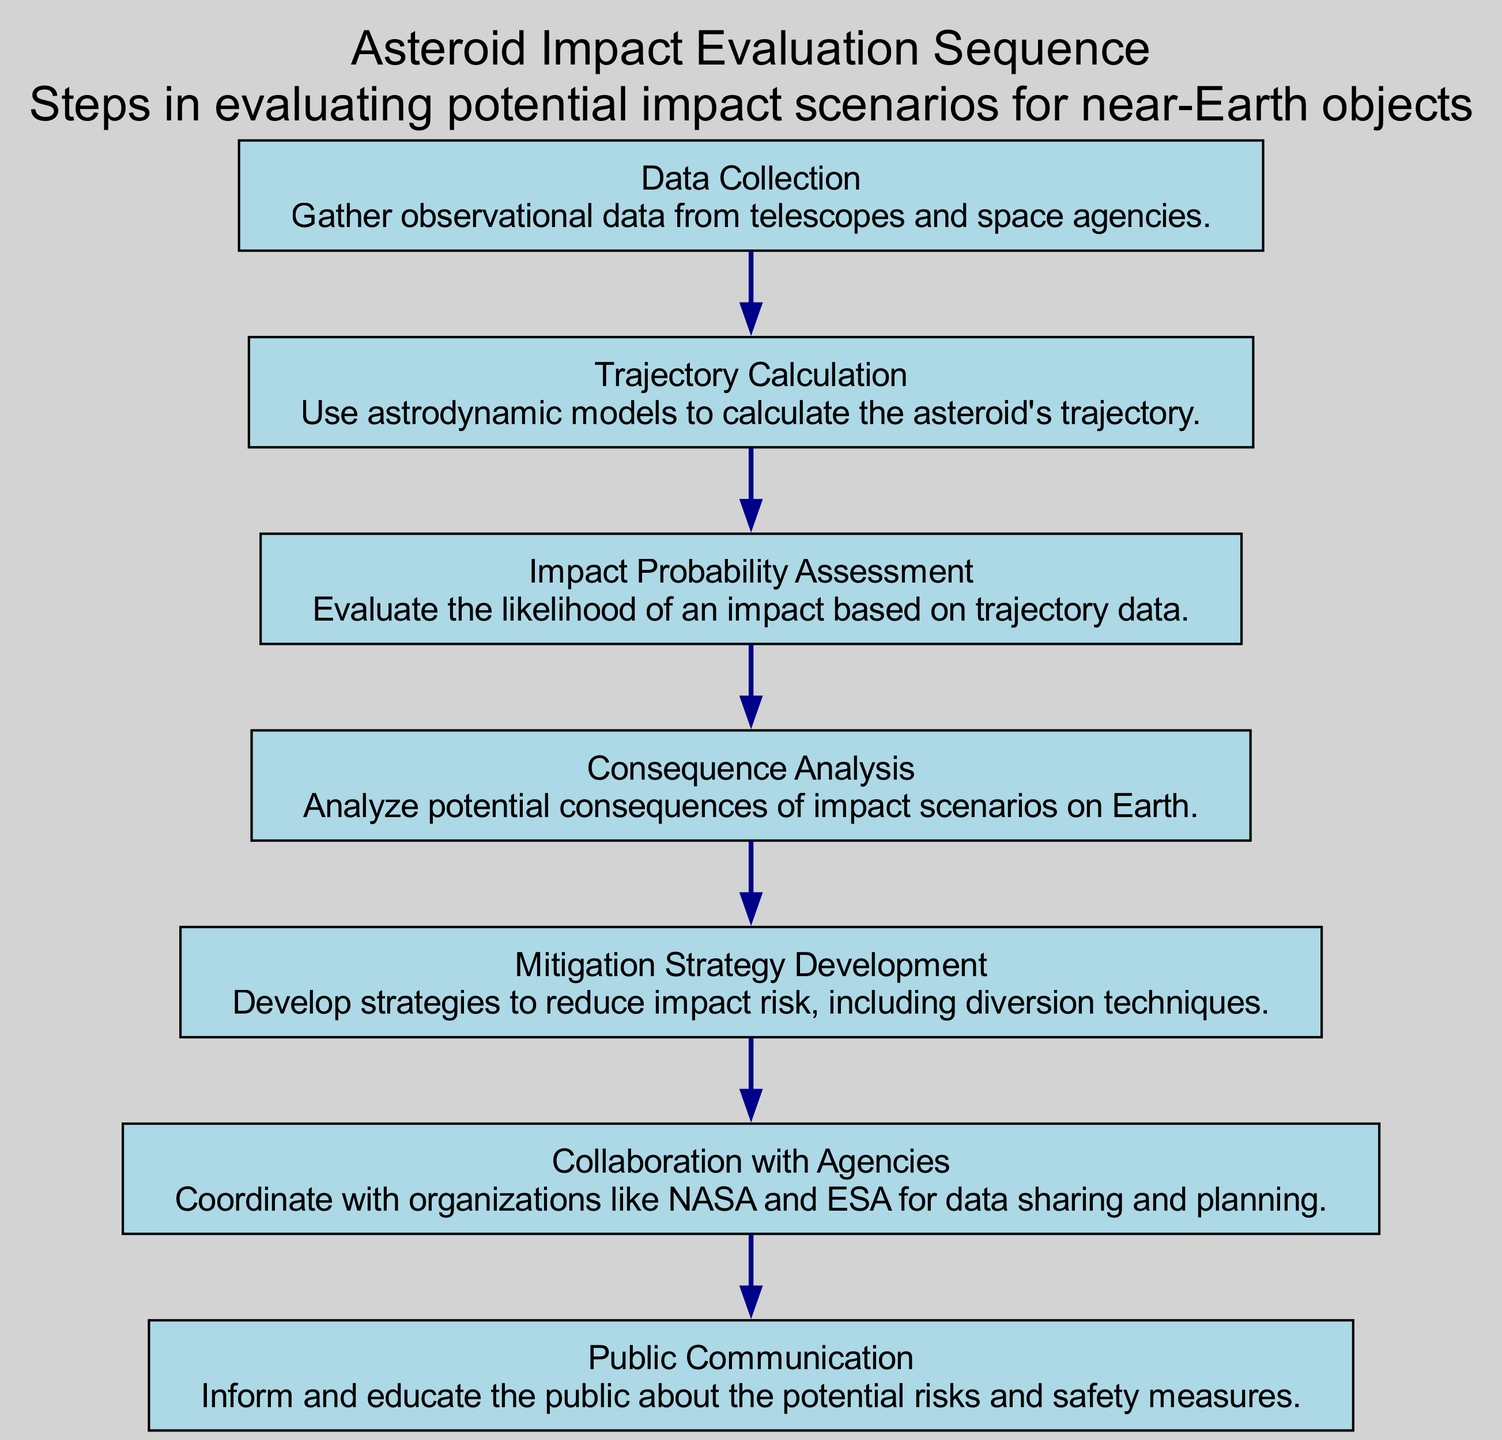What is the first step in the sequence? The diagram shows the first node named "Data Collection," indicating that the first step involves gathering observational data.
Answer: Data Collection How many total steps are there in the sequence? By counting the nodes in the diagram, there are a total of seven distinct steps outlined from Data Collection to Public Communication.
Answer: 7 What follows after Impact Probability Assessment? The information in the diagram indicates that the step "Consequence Analysis" follows directly after "Impact Probability Assessment."
Answer: Consequence Analysis Which step involves collaboration with organizations? The diagram specifies a step called "Collaboration with Agencies," which involves coordinating with organizations like NASA and ESA.
Answer: Collaboration with Agencies What is the last step in the sequence? Analyzing the diagram, the last step, which concludes the sequence, is labeled "Public Communication."
Answer: Public Communication How many steps involve assessment or analysis? By reviewing the steps, there are three specific steps that involve assessment or analysis: "Impact Probability Assessment," "Consequence Analysis," and "Mitigation Strategy Development."
Answer: 3 What is the relationship between Trajectory Calculation and Impact Probability Assessment? The edge in the diagram indicates a sequential flow from "Trajectory Calculation" to "Impact Probability Assessment," showing that calculating the trajectory is necessary before assessing impact probability.
Answer: Sequential flow What is the purpose of the Mitigation Strategy Development step? The description for "Mitigation Strategy Development" in the diagram states that it is about developing strategies to reduce impact risk through various techniques.
Answer: Reduce impact risk 